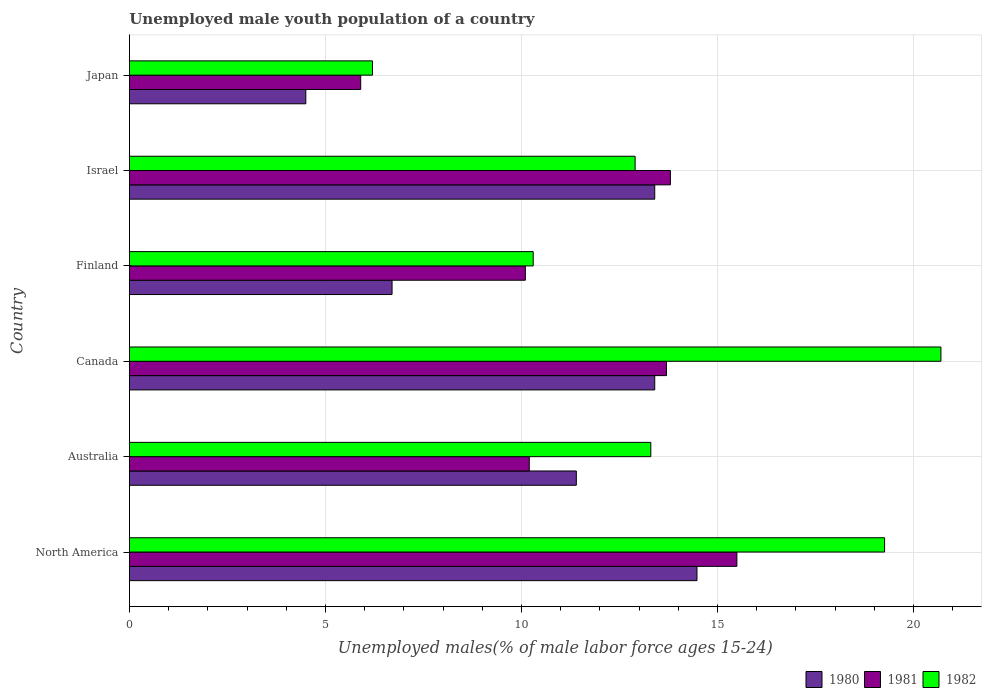How many different coloured bars are there?
Your answer should be compact. 3. How many groups of bars are there?
Your answer should be compact. 6. Are the number of bars per tick equal to the number of legend labels?
Ensure brevity in your answer.  Yes. Are the number of bars on each tick of the Y-axis equal?
Provide a short and direct response. Yes. How many bars are there on the 2nd tick from the top?
Make the answer very short. 3. How many bars are there on the 5th tick from the bottom?
Provide a short and direct response. 3. What is the label of the 3rd group of bars from the top?
Offer a very short reply. Finland. In how many cases, is the number of bars for a given country not equal to the number of legend labels?
Offer a terse response. 0. What is the percentage of unemployed male youth population in 1981 in Japan?
Give a very brief answer. 5.9. Across all countries, what is the maximum percentage of unemployed male youth population in 1981?
Make the answer very short. 15.5. Across all countries, what is the minimum percentage of unemployed male youth population in 1982?
Your response must be concise. 6.2. What is the total percentage of unemployed male youth population in 1982 in the graph?
Make the answer very short. 82.66. What is the difference between the percentage of unemployed male youth population in 1981 in Finland and that in Israel?
Offer a terse response. -3.7. What is the difference between the percentage of unemployed male youth population in 1980 in Japan and the percentage of unemployed male youth population in 1982 in Finland?
Make the answer very short. -5.8. What is the average percentage of unemployed male youth population in 1982 per country?
Offer a terse response. 13.78. What is the difference between the percentage of unemployed male youth population in 1980 and percentage of unemployed male youth population in 1982 in Australia?
Offer a very short reply. -1.9. In how many countries, is the percentage of unemployed male youth population in 1981 greater than 1 %?
Your response must be concise. 6. What is the ratio of the percentage of unemployed male youth population in 1980 in Australia to that in Japan?
Ensure brevity in your answer.  2.53. Is the percentage of unemployed male youth population in 1981 in Canada less than that in Japan?
Give a very brief answer. No. What is the difference between the highest and the second highest percentage of unemployed male youth population in 1981?
Make the answer very short. 1.7. What is the difference between the highest and the lowest percentage of unemployed male youth population in 1980?
Your response must be concise. 9.98. Is the sum of the percentage of unemployed male youth population in 1982 in Canada and North America greater than the maximum percentage of unemployed male youth population in 1980 across all countries?
Your response must be concise. Yes. What does the 2nd bar from the top in Australia represents?
Provide a succinct answer. 1981. Is it the case that in every country, the sum of the percentage of unemployed male youth population in 1982 and percentage of unemployed male youth population in 1980 is greater than the percentage of unemployed male youth population in 1981?
Make the answer very short. Yes. How many bars are there?
Your answer should be compact. 18. Are all the bars in the graph horizontal?
Ensure brevity in your answer.  Yes. How many countries are there in the graph?
Provide a short and direct response. 6. What is the difference between two consecutive major ticks on the X-axis?
Keep it short and to the point. 5. How many legend labels are there?
Ensure brevity in your answer.  3. What is the title of the graph?
Ensure brevity in your answer.  Unemployed male youth population of a country. What is the label or title of the X-axis?
Offer a very short reply. Unemployed males(% of male labor force ages 15-24). What is the Unemployed males(% of male labor force ages 15-24) of 1980 in North America?
Your response must be concise. 14.48. What is the Unemployed males(% of male labor force ages 15-24) in 1981 in North America?
Provide a succinct answer. 15.5. What is the Unemployed males(% of male labor force ages 15-24) of 1982 in North America?
Make the answer very short. 19.26. What is the Unemployed males(% of male labor force ages 15-24) in 1980 in Australia?
Provide a short and direct response. 11.4. What is the Unemployed males(% of male labor force ages 15-24) in 1981 in Australia?
Make the answer very short. 10.2. What is the Unemployed males(% of male labor force ages 15-24) in 1982 in Australia?
Your response must be concise. 13.3. What is the Unemployed males(% of male labor force ages 15-24) of 1980 in Canada?
Keep it short and to the point. 13.4. What is the Unemployed males(% of male labor force ages 15-24) of 1981 in Canada?
Your response must be concise. 13.7. What is the Unemployed males(% of male labor force ages 15-24) of 1982 in Canada?
Ensure brevity in your answer.  20.7. What is the Unemployed males(% of male labor force ages 15-24) in 1980 in Finland?
Ensure brevity in your answer.  6.7. What is the Unemployed males(% of male labor force ages 15-24) in 1981 in Finland?
Offer a very short reply. 10.1. What is the Unemployed males(% of male labor force ages 15-24) in 1982 in Finland?
Give a very brief answer. 10.3. What is the Unemployed males(% of male labor force ages 15-24) in 1980 in Israel?
Give a very brief answer. 13.4. What is the Unemployed males(% of male labor force ages 15-24) in 1981 in Israel?
Make the answer very short. 13.8. What is the Unemployed males(% of male labor force ages 15-24) in 1982 in Israel?
Your answer should be very brief. 12.9. What is the Unemployed males(% of male labor force ages 15-24) in 1980 in Japan?
Your answer should be compact. 4.5. What is the Unemployed males(% of male labor force ages 15-24) of 1981 in Japan?
Offer a terse response. 5.9. What is the Unemployed males(% of male labor force ages 15-24) in 1982 in Japan?
Your answer should be compact. 6.2. Across all countries, what is the maximum Unemployed males(% of male labor force ages 15-24) in 1980?
Ensure brevity in your answer.  14.48. Across all countries, what is the maximum Unemployed males(% of male labor force ages 15-24) of 1981?
Give a very brief answer. 15.5. Across all countries, what is the maximum Unemployed males(% of male labor force ages 15-24) in 1982?
Provide a short and direct response. 20.7. Across all countries, what is the minimum Unemployed males(% of male labor force ages 15-24) in 1980?
Your answer should be compact. 4.5. Across all countries, what is the minimum Unemployed males(% of male labor force ages 15-24) in 1981?
Your response must be concise. 5.9. Across all countries, what is the minimum Unemployed males(% of male labor force ages 15-24) of 1982?
Ensure brevity in your answer.  6.2. What is the total Unemployed males(% of male labor force ages 15-24) of 1980 in the graph?
Provide a short and direct response. 63.88. What is the total Unemployed males(% of male labor force ages 15-24) of 1981 in the graph?
Offer a very short reply. 69.2. What is the total Unemployed males(% of male labor force ages 15-24) in 1982 in the graph?
Your answer should be very brief. 82.66. What is the difference between the Unemployed males(% of male labor force ages 15-24) of 1980 in North America and that in Australia?
Provide a succinct answer. 3.08. What is the difference between the Unemployed males(% of male labor force ages 15-24) of 1981 in North America and that in Australia?
Provide a succinct answer. 5.3. What is the difference between the Unemployed males(% of male labor force ages 15-24) of 1982 in North America and that in Australia?
Your answer should be very brief. 5.96. What is the difference between the Unemployed males(% of male labor force ages 15-24) of 1980 in North America and that in Canada?
Make the answer very short. 1.08. What is the difference between the Unemployed males(% of male labor force ages 15-24) of 1981 in North America and that in Canada?
Make the answer very short. 1.8. What is the difference between the Unemployed males(% of male labor force ages 15-24) of 1982 in North America and that in Canada?
Offer a terse response. -1.44. What is the difference between the Unemployed males(% of male labor force ages 15-24) in 1980 in North America and that in Finland?
Offer a terse response. 7.78. What is the difference between the Unemployed males(% of male labor force ages 15-24) of 1981 in North America and that in Finland?
Offer a very short reply. 5.4. What is the difference between the Unemployed males(% of male labor force ages 15-24) in 1982 in North America and that in Finland?
Give a very brief answer. 8.96. What is the difference between the Unemployed males(% of male labor force ages 15-24) in 1980 in North America and that in Israel?
Make the answer very short. 1.08. What is the difference between the Unemployed males(% of male labor force ages 15-24) of 1981 in North America and that in Israel?
Keep it short and to the point. 1.7. What is the difference between the Unemployed males(% of male labor force ages 15-24) of 1982 in North America and that in Israel?
Keep it short and to the point. 6.36. What is the difference between the Unemployed males(% of male labor force ages 15-24) of 1980 in North America and that in Japan?
Give a very brief answer. 9.98. What is the difference between the Unemployed males(% of male labor force ages 15-24) in 1981 in North America and that in Japan?
Offer a terse response. 9.6. What is the difference between the Unemployed males(% of male labor force ages 15-24) of 1982 in North America and that in Japan?
Make the answer very short. 13.06. What is the difference between the Unemployed males(% of male labor force ages 15-24) of 1980 in Australia and that in Canada?
Offer a terse response. -2. What is the difference between the Unemployed males(% of male labor force ages 15-24) of 1980 in Australia and that in Finland?
Offer a terse response. 4.7. What is the difference between the Unemployed males(% of male labor force ages 15-24) of 1981 in Australia and that in Finland?
Your response must be concise. 0.1. What is the difference between the Unemployed males(% of male labor force ages 15-24) of 1982 in Australia and that in Finland?
Provide a succinct answer. 3. What is the difference between the Unemployed males(% of male labor force ages 15-24) in 1980 in Australia and that in Israel?
Give a very brief answer. -2. What is the difference between the Unemployed males(% of male labor force ages 15-24) in 1982 in Australia and that in Israel?
Your answer should be compact. 0.4. What is the difference between the Unemployed males(% of male labor force ages 15-24) in 1980 in Australia and that in Japan?
Ensure brevity in your answer.  6.9. What is the difference between the Unemployed males(% of male labor force ages 15-24) in 1982 in Australia and that in Japan?
Your response must be concise. 7.1. What is the difference between the Unemployed males(% of male labor force ages 15-24) of 1980 in Canada and that in Finland?
Ensure brevity in your answer.  6.7. What is the difference between the Unemployed males(% of male labor force ages 15-24) of 1981 in Canada and that in Finland?
Make the answer very short. 3.6. What is the difference between the Unemployed males(% of male labor force ages 15-24) in 1981 in Canada and that in Japan?
Offer a terse response. 7.8. What is the difference between the Unemployed males(% of male labor force ages 15-24) of 1982 in Canada and that in Japan?
Offer a terse response. 14.5. What is the difference between the Unemployed males(% of male labor force ages 15-24) of 1982 in Finland and that in Israel?
Your answer should be compact. -2.6. What is the difference between the Unemployed males(% of male labor force ages 15-24) of 1982 in Israel and that in Japan?
Offer a very short reply. 6.7. What is the difference between the Unemployed males(% of male labor force ages 15-24) of 1980 in North America and the Unemployed males(% of male labor force ages 15-24) of 1981 in Australia?
Offer a very short reply. 4.28. What is the difference between the Unemployed males(% of male labor force ages 15-24) of 1980 in North America and the Unemployed males(% of male labor force ages 15-24) of 1982 in Australia?
Your answer should be compact. 1.18. What is the difference between the Unemployed males(% of male labor force ages 15-24) in 1981 in North America and the Unemployed males(% of male labor force ages 15-24) in 1982 in Australia?
Your answer should be compact. 2.2. What is the difference between the Unemployed males(% of male labor force ages 15-24) of 1980 in North America and the Unemployed males(% of male labor force ages 15-24) of 1981 in Canada?
Keep it short and to the point. 0.78. What is the difference between the Unemployed males(% of male labor force ages 15-24) of 1980 in North America and the Unemployed males(% of male labor force ages 15-24) of 1982 in Canada?
Your answer should be compact. -6.22. What is the difference between the Unemployed males(% of male labor force ages 15-24) of 1981 in North America and the Unemployed males(% of male labor force ages 15-24) of 1982 in Canada?
Offer a terse response. -5.2. What is the difference between the Unemployed males(% of male labor force ages 15-24) in 1980 in North America and the Unemployed males(% of male labor force ages 15-24) in 1981 in Finland?
Provide a short and direct response. 4.38. What is the difference between the Unemployed males(% of male labor force ages 15-24) of 1980 in North America and the Unemployed males(% of male labor force ages 15-24) of 1982 in Finland?
Your answer should be compact. 4.18. What is the difference between the Unemployed males(% of male labor force ages 15-24) of 1981 in North America and the Unemployed males(% of male labor force ages 15-24) of 1982 in Finland?
Give a very brief answer. 5.2. What is the difference between the Unemployed males(% of male labor force ages 15-24) of 1980 in North America and the Unemployed males(% of male labor force ages 15-24) of 1981 in Israel?
Provide a succinct answer. 0.68. What is the difference between the Unemployed males(% of male labor force ages 15-24) of 1980 in North America and the Unemployed males(% of male labor force ages 15-24) of 1982 in Israel?
Provide a short and direct response. 1.58. What is the difference between the Unemployed males(% of male labor force ages 15-24) of 1981 in North America and the Unemployed males(% of male labor force ages 15-24) of 1982 in Israel?
Offer a very short reply. 2.6. What is the difference between the Unemployed males(% of male labor force ages 15-24) of 1980 in North America and the Unemployed males(% of male labor force ages 15-24) of 1981 in Japan?
Provide a succinct answer. 8.58. What is the difference between the Unemployed males(% of male labor force ages 15-24) in 1980 in North America and the Unemployed males(% of male labor force ages 15-24) in 1982 in Japan?
Your answer should be very brief. 8.28. What is the difference between the Unemployed males(% of male labor force ages 15-24) in 1981 in North America and the Unemployed males(% of male labor force ages 15-24) in 1982 in Japan?
Make the answer very short. 9.3. What is the difference between the Unemployed males(% of male labor force ages 15-24) in 1980 in Australia and the Unemployed males(% of male labor force ages 15-24) in 1982 in Canada?
Your answer should be very brief. -9.3. What is the difference between the Unemployed males(% of male labor force ages 15-24) of 1981 in Australia and the Unemployed males(% of male labor force ages 15-24) of 1982 in Canada?
Your answer should be compact. -10.5. What is the difference between the Unemployed males(% of male labor force ages 15-24) of 1980 in Australia and the Unemployed males(% of male labor force ages 15-24) of 1981 in Finland?
Make the answer very short. 1.3. What is the difference between the Unemployed males(% of male labor force ages 15-24) of 1981 in Australia and the Unemployed males(% of male labor force ages 15-24) of 1982 in Finland?
Give a very brief answer. -0.1. What is the difference between the Unemployed males(% of male labor force ages 15-24) of 1980 in Australia and the Unemployed males(% of male labor force ages 15-24) of 1981 in Israel?
Your answer should be very brief. -2.4. What is the difference between the Unemployed males(% of male labor force ages 15-24) in 1980 in Australia and the Unemployed males(% of male labor force ages 15-24) in 1981 in Japan?
Your answer should be very brief. 5.5. What is the difference between the Unemployed males(% of male labor force ages 15-24) of 1980 in Australia and the Unemployed males(% of male labor force ages 15-24) of 1982 in Japan?
Your answer should be very brief. 5.2. What is the difference between the Unemployed males(% of male labor force ages 15-24) in 1981 in Australia and the Unemployed males(% of male labor force ages 15-24) in 1982 in Japan?
Provide a succinct answer. 4. What is the difference between the Unemployed males(% of male labor force ages 15-24) of 1980 in Canada and the Unemployed males(% of male labor force ages 15-24) of 1981 in Finland?
Your answer should be very brief. 3.3. What is the difference between the Unemployed males(% of male labor force ages 15-24) in 1980 in Canada and the Unemployed males(% of male labor force ages 15-24) in 1982 in Finland?
Ensure brevity in your answer.  3.1. What is the difference between the Unemployed males(% of male labor force ages 15-24) of 1981 in Canada and the Unemployed males(% of male labor force ages 15-24) of 1982 in Finland?
Keep it short and to the point. 3.4. What is the difference between the Unemployed males(% of male labor force ages 15-24) of 1980 in Canada and the Unemployed males(% of male labor force ages 15-24) of 1981 in Israel?
Offer a terse response. -0.4. What is the difference between the Unemployed males(% of male labor force ages 15-24) of 1981 in Canada and the Unemployed males(% of male labor force ages 15-24) of 1982 in Israel?
Offer a very short reply. 0.8. What is the difference between the Unemployed males(% of male labor force ages 15-24) in 1980 in Canada and the Unemployed males(% of male labor force ages 15-24) in 1982 in Japan?
Provide a succinct answer. 7.2. What is the difference between the Unemployed males(% of male labor force ages 15-24) in 1980 in Finland and the Unemployed males(% of male labor force ages 15-24) in 1981 in Israel?
Your response must be concise. -7.1. What is the difference between the Unemployed males(% of male labor force ages 15-24) of 1980 in Finland and the Unemployed males(% of male labor force ages 15-24) of 1982 in Israel?
Keep it short and to the point. -6.2. What is the difference between the Unemployed males(% of male labor force ages 15-24) of 1981 in Finland and the Unemployed males(% of male labor force ages 15-24) of 1982 in Israel?
Your answer should be compact. -2.8. What is the difference between the Unemployed males(% of male labor force ages 15-24) of 1980 in Finland and the Unemployed males(% of male labor force ages 15-24) of 1982 in Japan?
Give a very brief answer. 0.5. What is the difference between the Unemployed males(% of male labor force ages 15-24) of 1981 in Finland and the Unemployed males(% of male labor force ages 15-24) of 1982 in Japan?
Give a very brief answer. 3.9. What is the difference between the Unemployed males(% of male labor force ages 15-24) of 1980 in Israel and the Unemployed males(% of male labor force ages 15-24) of 1982 in Japan?
Keep it short and to the point. 7.2. What is the average Unemployed males(% of male labor force ages 15-24) of 1980 per country?
Make the answer very short. 10.65. What is the average Unemployed males(% of male labor force ages 15-24) of 1981 per country?
Provide a short and direct response. 11.53. What is the average Unemployed males(% of male labor force ages 15-24) of 1982 per country?
Your answer should be compact. 13.78. What is the difference between the Unemployed males(% of male labor force ages 15-24) in 1980 and Unemployed males(% of male labor force ages 15-24) in 1981 in North America?
Provide a short and direct response. -1.02. What is the difference between the Unemployed males(% of male labor force ages 15-24) in 1980 and Unemployed males(% of male labor force ages 15-24) in 1982 in North America?
Provide a succinct answer. -4.79. What is the difference between the Unemployed males(% of male labor force ages 15-24) in 1981 and Unemployed males(% of male labor force ages 15-24) in 1982 in North America?
Your answer should be very brief. -3.77. What is the difference between the Unemployed males(% of male labor force ages 15-24) in 1980 and Unemployed males(% of male labor force ages 15-24) in 1981 in Australia?
Provide a short and direct response. 1.2. What is the difference between the Unemployed males(% of male labor force ages 15-24) of 1981 and Unemployed males(% of male labor force ages 15-24) of 1982 in Australia?
Offer a very short reply. -3.1. What is the difference between the Unemployed males(% of male labor force ages 15-24) of 1980 and Unemployed males(% of male labor force ages 15-24) of 1982 in Canada?
Offer a terse response. -7.3. What is the difference between the Unemployed males(% of male labor force ages 15-24) of 1980 and Unemployed males(% of male labor force ages 15-24) of 1982 in Finland?
Your answer should be very brief. -3.6. What is the difference between the Unemployed males(% of male labor force ages 15-24) in 1981 and Unemployed males(% of male labor force ages 15-24) in 1982 in Finland?
Your answer should be very brief. -0.2. What is the difference between the Unemployed males(% of male labor force ages 15-24) in 1980 and Unemployed males(% of male labor force ages 15-24) in 1981 in Israel?
Provide a short and direct response. -0.4. What is the difference between the Unemployed males(% of male labor force ages 15-24) of 1980 and Unemployed males(% of male labor force ages 15-24) of 1981 in Japan?
Your answer should be very brief. -1.4. What is the difference between the Unemployed males(% of male labor force ages 15-24) in 1980 and Unemployed males(% of male labor force ages 15-24) in 1982 in Japan?
Offer a terse response. -1.7. What is the difference between the Unemployed males(% of male labor force ages 15-24) of 1981 and Unemployed males(% of male labor force ages 15-24) of 1982 in Japan?
Ensure brevity in your answer.  -0.3. What is the ratio of the Unemployed males(% of male labor force ages 15-24) of 1980 in North America to that in Australia?
Your response must be concise. 1.27. What is the ratio of the Unemployed males(% of male labor force ages 15-24) of 1981 in North America to that in Australia?
Your response must be concise. 1.52. What is the ratio of the Unemployed males(% of male labor force ages 15-24) of 1982 in North America to that in Australia?
Give a very brief answer. 1.45. What is the ratio of the Unemployed males(% of male labor force ages 15-24) in 1980 in North America to that in Canada?
Your answer should be compact. 1.08. What is the ratio of the Unemployed males(% of male labor force ages 15-24) in 1981 in North America to that in Canada?
Make the answer very short. 1.13. What is the ratio of the Unemployed males(% of male labor force ages 15-24) of 1982 in North America to that in Canada?
Ensure brevity in your answer.  0.93. What is the ratio of the Unemployed males(% of male labor force ages 15-24) in 1980 in North America to that in Finland?
Your response must be concise. 2.16. What is the ratio of the Unemployed males(% of male labor force ages 15-24) in 1981 in North America to that in Finland?
Offer a very short reply. 1.53. What is the ratio of the Unemployed males(% of male labor force ages 15-24) of 1982 in North America to that in Finland?
Keep it short and to the point. 1.87. What is the ratio of the Unemployed males(% of male labor force ages 15-24) of 1980 in North America to that in Israel?
Your answer should be compact. 1.08. What is the ratio of the Unemployed males(% of male labor force ages 15-24) of 1981 in North America to that in Israel?
Make the answer very short. 1.12. What is the ratio of the Unemployed males(% of male labor force ages 15-24) in 1982 in North America to that in Israel?
Offer a very short reply. 1.49. What is the ratio of the Unemployed males(% of male labor force ages 15-24) of 1980 in North America to that in Japan?
Make the answer very short. 3.22. What is the ratio of the Unemployed males(% of male labor force ages 15-24) in 1981 in North America to that in Japan?
Provide a succinct answer. 2.63. What is the ratio of the Unemployed males(% of male labor force ages 15-24) of 1982 in North America to that in Japan?
Offer a very short reply. 3.11. What is the ratio of the Unemployed males(% of male labor force ages 15-24) in 1980 in Australia to that in Canada?
Provide a succinct answer. 0.85. What is the ratio of the Unemployed males(% of male labor force ages 15-24) of 1981 in Australia to that in Canada?
Offer a very short reply. 0.74. What is the ratio of the Unemployed males(% of male labor force ages 15-24) in 1982 in Australia to that in Canada?
Provide a short and direct response. 0.64. What is the ratio of the Unemployed males(% of male labor force ages 15-24) in 1980 in Australia to that in Finland?
Offer a terse response. 1.7. What is the ratio of the Unemployed males(% of male labor force ages 15-24) in 1981 in Australia to that in Finland?
Ensure brevity in your answer.  1.01. What is the ratio of the Unemployed males(% of male labor force ages 15-24) in 1982 in Australia to that in Finland?
Keep it short and to the point. 1.29. What is the ratio of the Unemployed males(% of male labor force ages 15-24) in 1980 in Australia to that in Israel?
Your answer should be compact. 0.85. What is the ratio of the Unemployed males(% of male labor force ages 15-24) of 1981 in Australia to that in Israel?
Keep it short and to the point. 0.74. What is the ratio of the Unemployed males(% of male labor force ages 15-24) of 1982 in Australia to that in Israel?
Your response must be concise. 1.03. What is the ratio of the Unemployed males(% of male labor force ages 15-24) of 1980 in Australia to that in Japan?
Make the answer very short. 2.53. What is the ratio of the Unemployed males(% of male labor force ages 15-24) of 1981 in Australia to that in Japan?
Offer a very short reply. 1.73. What is the ratio of the Unemployed males(% of male labor force ages 15-24) in 1982 in Australia to that in Japan?
Give a very brief answer. 2.15. What is the ratio of the Unemployed males(% of male labor force ages 15-24) in 1980 in Canada to that in Finland?
Provide a short and direct response. 2. What is the ratio of the Unemployed males(% of male labor force ages 15-24) in 1981 in Canada to that in Finland?
Provide a short and direct response. 1.36. What is the ratio of the Unemployed males(% of male labor force ages 15-24) in 1982 in Canada to that in Finland?
Offer a terse response. 2.01. What is the ratio of the Unemployed males(% of male labor force ages 15-24) in 1980 in Canada to that in Israel?
Make the answer very short. 1. What is the ratio of the Unemployed males(% of male labor force ages 15-24) in 1982 in Canada to that in Israel?
Make the answer very short. 1.6. What is the ratio of the Unemployed males(% of male labor force ages 15-24) of 1980 in Canada to that in Japan?
Offer a very short reply. 2.98. What is the ratio of the Unemployed males(% of male labor force ages 15-24) of 1981 in Canada to that in Japan?
Offer a very short reply. 2.32. What is the ratio of the Unemployed males(% of male labor force ages 15-24) in 1982 in Canada to that in Japan?
Provide a short and direct response. 3.34. What is the ratio of the Unemployed males(% of male labor force ages 15-24) of 1981 in Finland to that in Israel?
Your answer should be very brief. 0.73. What is the ratio of the Unemployed males(% of male labor force ages 15-24) in 1982 in Finland to that in Israel?
Provide a succinct answer. 0.8. What is the ratio of the Unemployed males(% of male labor force ages 15-24) of 1980 in Finland to that in Japan?
Offer a very short reply. 1.49. What is the ratio of the Unemployed males(% of male labor force ages 15-24) in 1981 in Finland to that in Japan?
Offer a very short reply. 1.71. What is the ratio of the Unemployed males(% of male labor force ages 15-24) of 1982 in Finland to that in Japan?
Ensure brevity in your answer.  1.66. What is the ratio of the Unemployed males(% of male labor force ages 15-24) of 1980 in Israel to that in Japan?
Give a very brief answer. 2.98. What is the ratio of the Unemployed males(% of male labor force ages 15-24) of 1981 in Israel to that in Japan?
Your answer should be compact. 2.34. What is the ratio of the Unemployed males(% of male labor force ages 15-24) in 1982 in Israel to that in Japan?
Provide a succinct answer. 2.08. What is the difference between the highest and the second highest Unemployed males(% of male labor force ages 15-24) of 1980?
Your answer should be very brief. 1.08. What is the difference between the highest and the second highest Unemployed males(% of male labor force ages 15-24) in 1981?
Offer a terse response. 1.7. What is the difference between the highest and the second highest Unemployed males(% of male labor force ages 15-24) of 1982?
Your answer should be compact. 1.44. What is the difference between the highest and the lowest Unemployed males(% of male labor force ages 15-24) of 1980?
Provide a short and direct response. 9.98. What is the difference between the highest and the lowest Unemployed males(% of male labor force ages 15-24) of 1981?
Your answer should be compact. 9.6. 